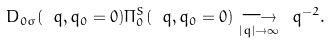Convert formula to latex. <formula><loc_0><loc_0><loc_500><loc_500>D _ { 0 \sigma } ( \ q , q _ { 0 } = 0 ) \Pi _ { 0 } ^ { S } ( \ q , q _ { 0 } = 0 ) \underset { | { q } | \to \infty } \longrightarrow \ q ^ { - 2 } .</formula> 